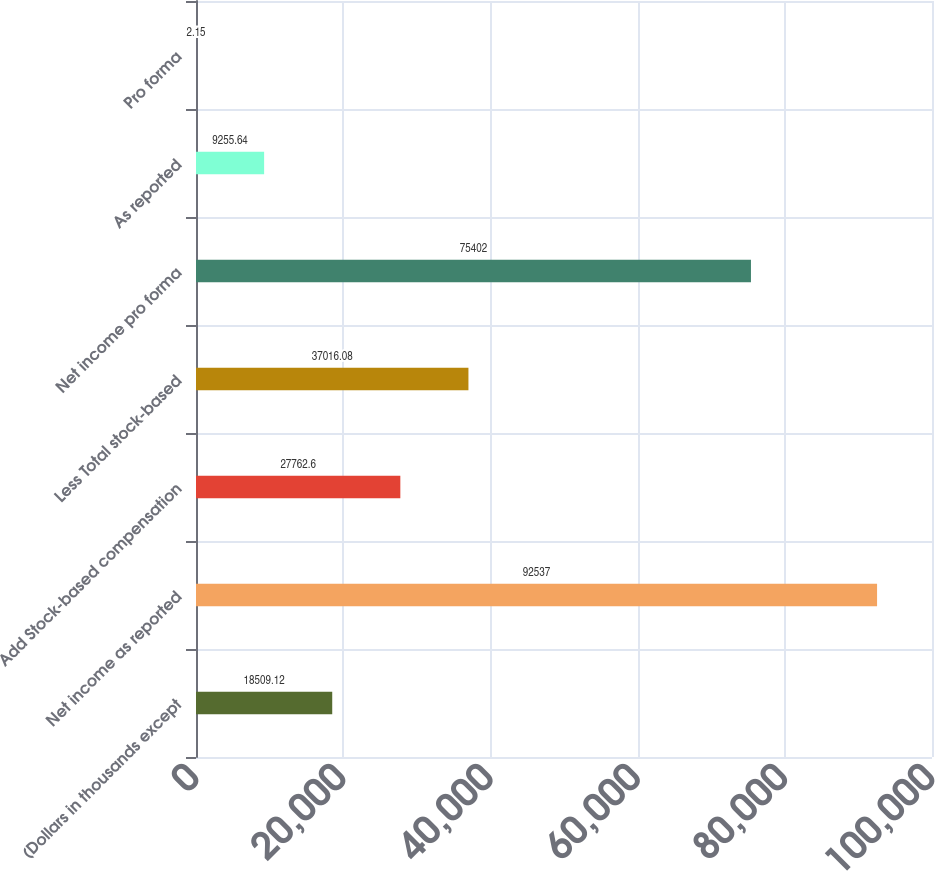Convert chart. <chart><loc_0><loc_0><loc_500><loc_500><bar_chart><fcel>(Dollars in thousands except<fcel>Net income as reported<fcel>Add Stock-based compensation<fcel>Less Total stock-based<fcel>Net income pro forma<fcel>As reported<fcel>Pro forma<nl><fcel>18509.1<fcel>92537<fcel>27762.6<fcel>37016.1<fcel>75402<fcel>9255.64<fcel>2.15<nl></chart> 